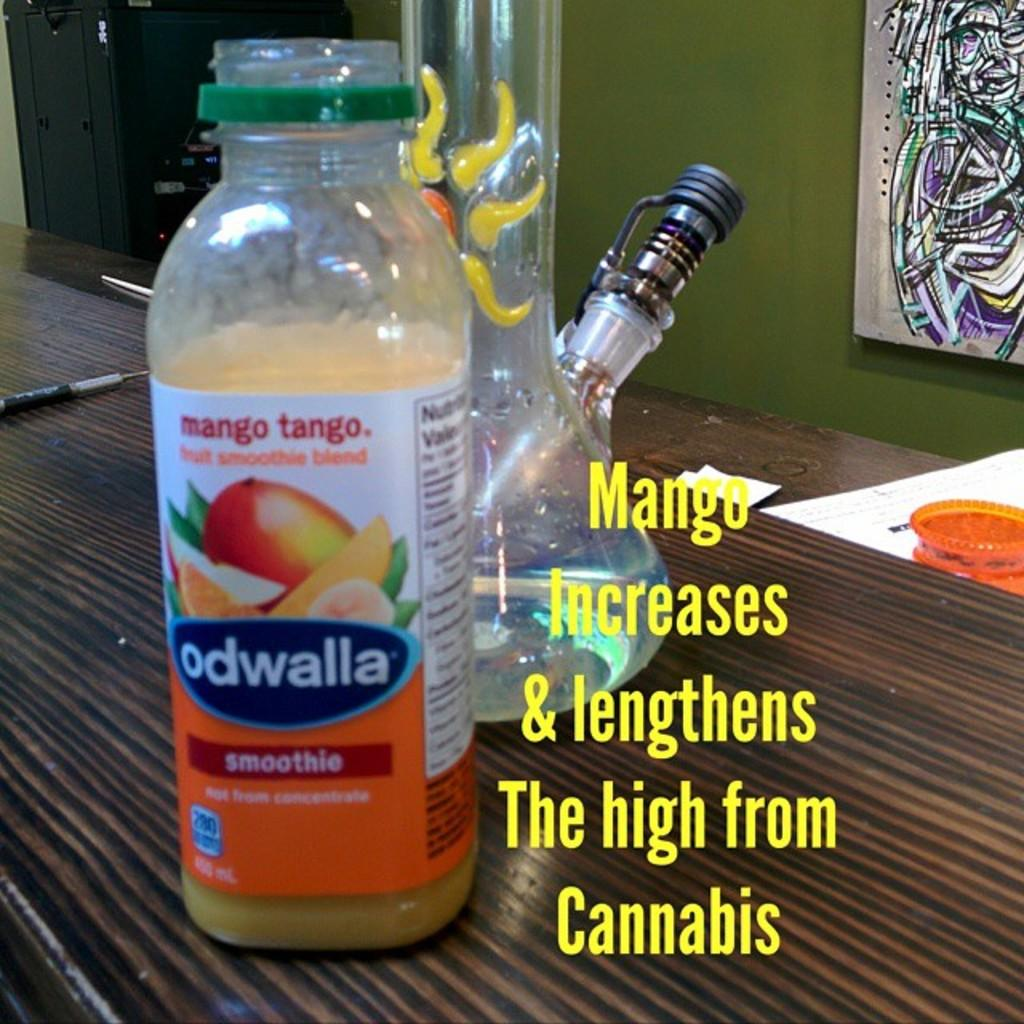<image>
Describe the image concisely. The bottle of Odwalla mango tango smoothie sits on a bar top next to a bong. 